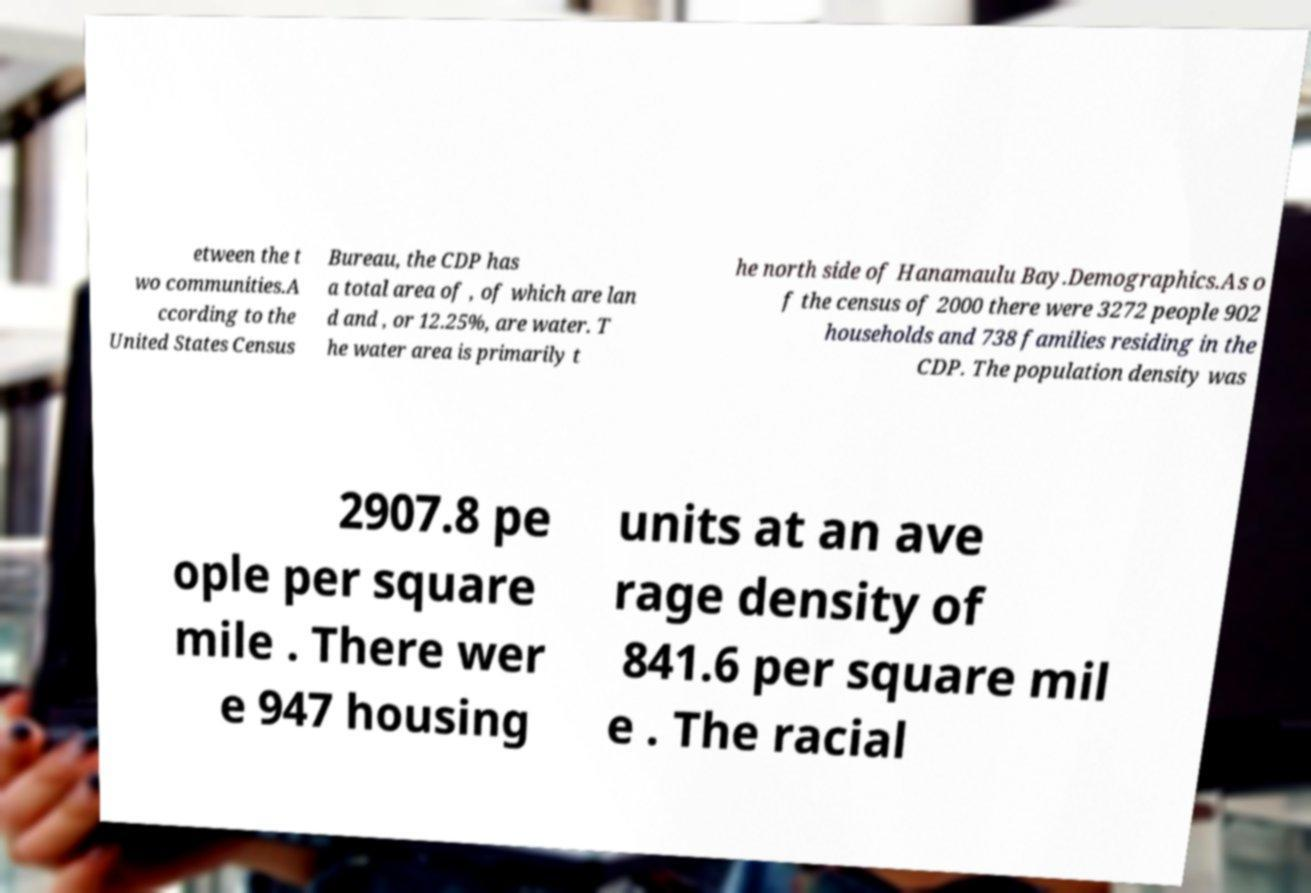Could you assist in decoding the text presented in this image and type it out clearly? etween the t wo communities.A ccording to the United States Census Bureau, the CDP has a total area of , of which are lan d and , or 12.25%, are water. T he water area is primarily t he north side of Hanamaulu Bay.Demographics.As o f the census of 2000 there were 3272 people 902 households and 738 families residing in the CDP. The population density was 2907.8 pe ople per square mile . There wer e 947 housing units at an ave rage density of 841.6 per square mil e . The racial 